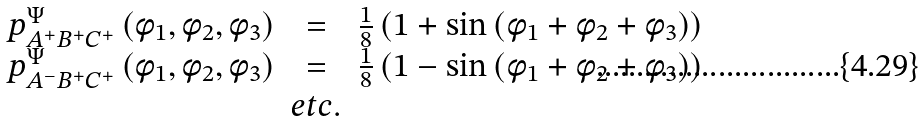<formula> <loc_0><loc_0><loc_500><loc_500>\begin{array} { r c l } p ^ { \Psi } _ { A ^ { + } B ^ { + } C ^ { + } } \left ( \phi _ { 1 } , \phi _ { 2 } , \phi _ { 3 } \right ) & = & \frac { 1 } { 8 } \left ( 1 + \sin \left ( \phi _ { 1 } + \phi _ { 2 } + \phi _ { 3 } \right ) \right ) \\ p ^ { \Psi } _ { A ^ { - } B ^ { + } C ^ { + } } \left ( \phi _ { 1 } , \phi _ { 2 } , \phi _ { 3 } \right ) & = & \frac { 1 } { 8 } \left ( 1 - \sin \left ( \phi _ { 1 } + \phi _ { 2 } + \phi _ { 3 } \right ) \right ) \\ & e t c . & \end{array}</formula> 